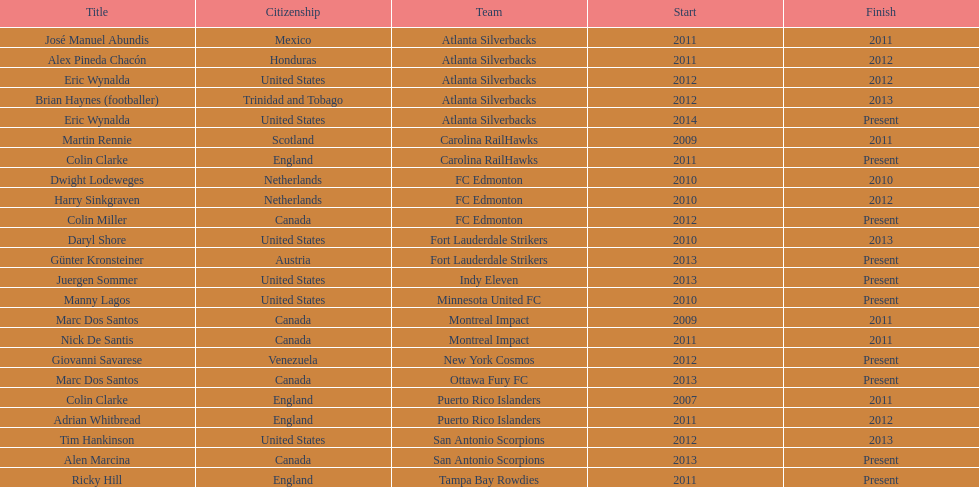How long did colin clarke coach the puerto rico islanders? 4 years. 